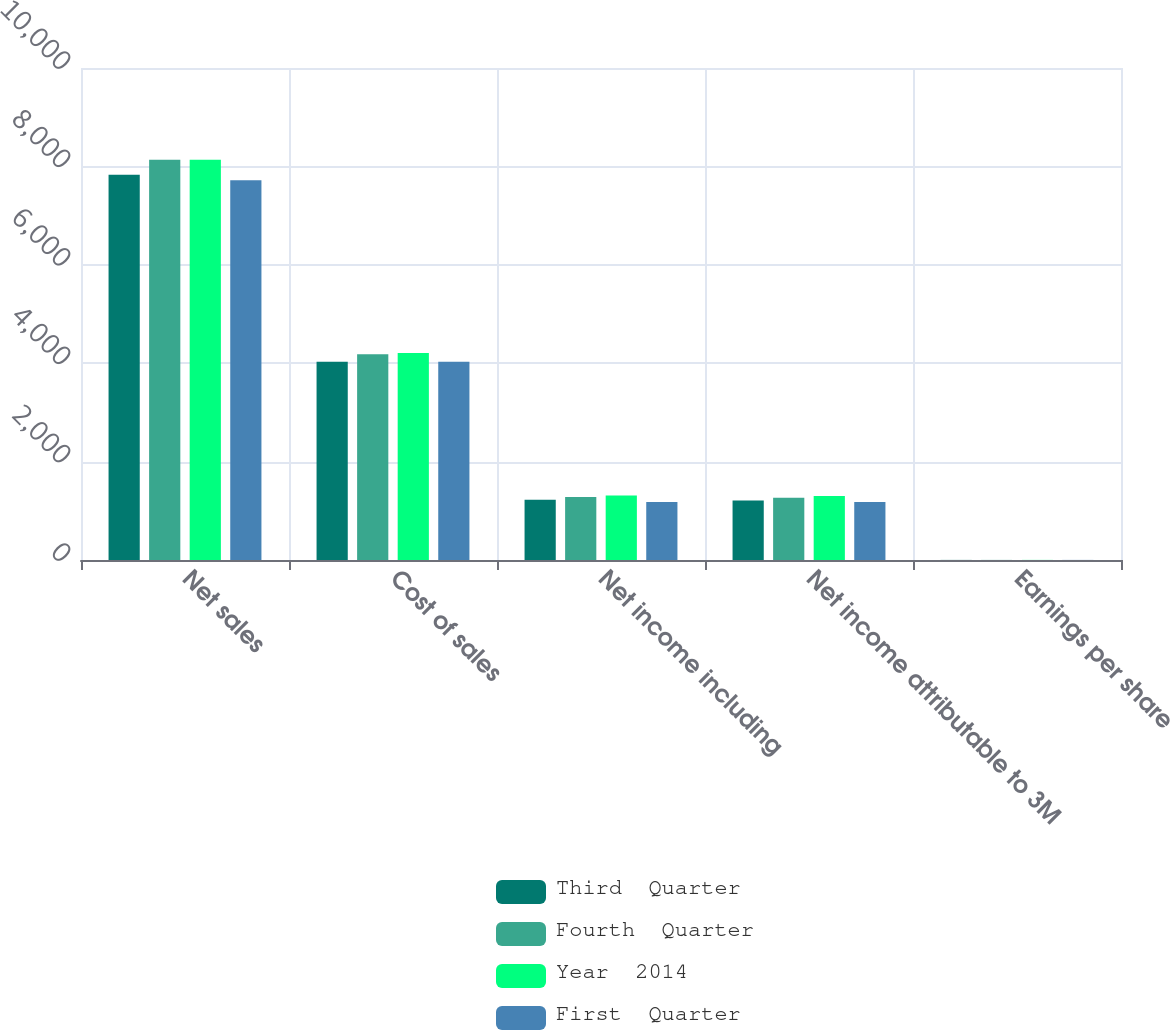Convert chart to OTSL. <chart><loc_0><loc_0><loc_500><loc_500><stacked_bar_chart><ecel><fcel>Net sales<fcel>Cost of sales<fcel>Net income including<fcel>Net income attributable to 3M<fcel>Earnings per share<nl><fcel>Third  Quarter<fcel>7831<fcel>4031<fcel>1225<fcel>1207<fcel>1.79<nl><fcel>Fourth  Quarter<fcel>8134<fcel>4184<fcel>1283<fcel>1267<fcel>1.91<nl><fcel>Year  2014<fcel>8137<fcel>4205<fcel>1311<fcel>1303<fcel>1.98<nl><fcel>First  Quarter<fcel>7719<fcel>4027<fcel>1179<fcel>1179<fcel>1.81<nl></chart> 